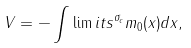Convert formula to latex. <formula><loc_0><loc_0><loc_500><loc_500>V = - \int \lim i t s ^ { \sigma _ { c } } m _ { 0 } { ( x ) } d x ,</formula> 